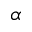<formula> <loc_0><loc_0><loc_500><loc_500>\alpha</formula> 